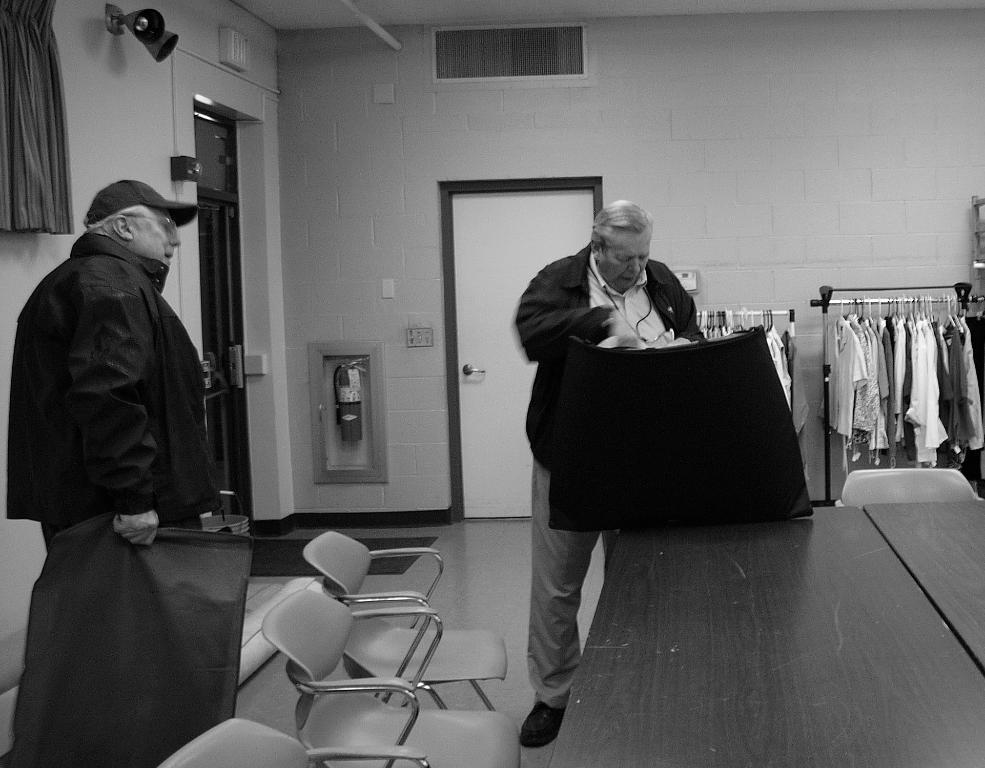How would you summarize this image in a sentence or two? This is a black and white picture. there are two men standing. This is a table. these are the empty chairs. I can see some clothes hanging to the hangers. This is the door with the door handle and this looks like a fire exhauster. 